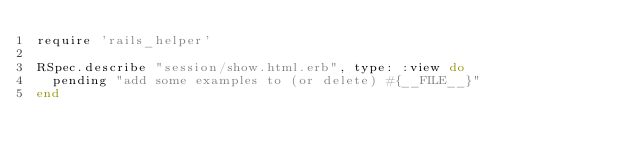Convert code to text. <code><loc_0><loc_0><loc_500><loc_500><_Ruby_>require 'rails_helper'

RSpec.describe "session/show.html.erb", type: :view do
  pending "add some examples to (or delete) #{__FILE__}"
end
</code> 